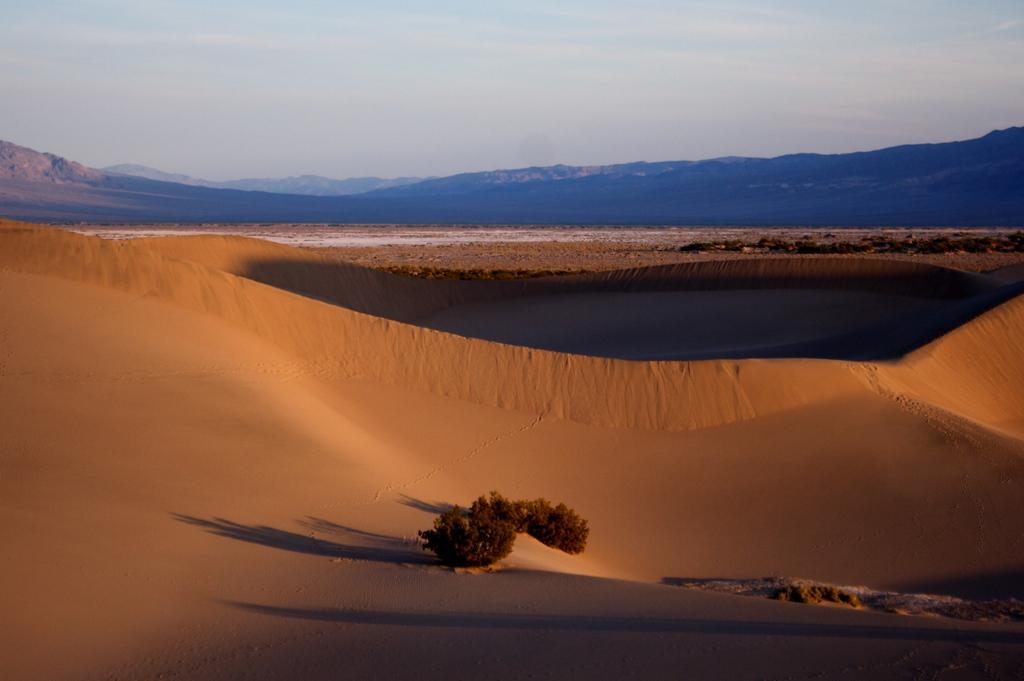Please provide a concise description of this image. In the picture I can see the dessert, trees, hills and the plain sky in the background. 